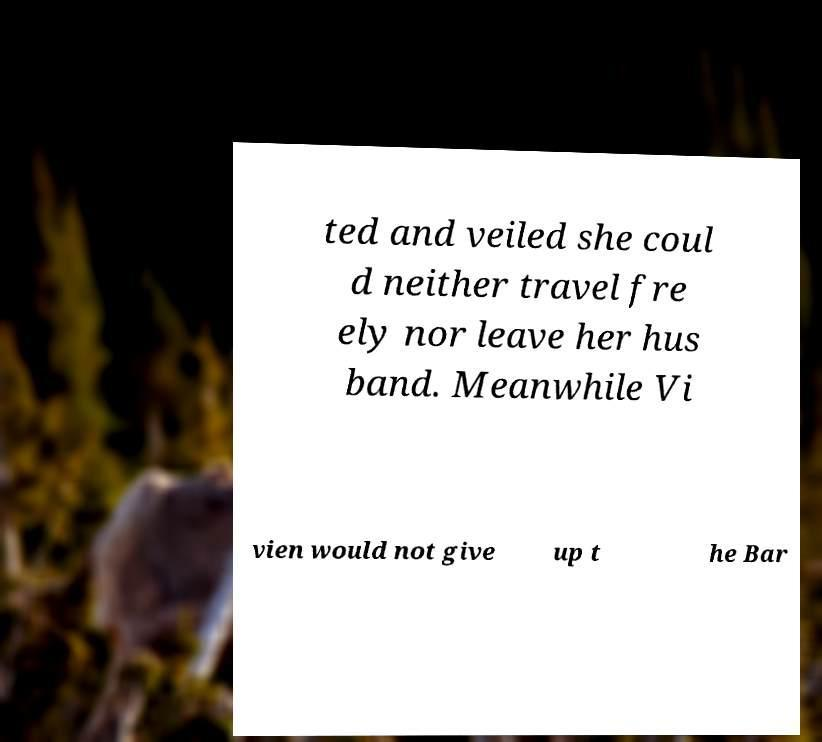Can you accurately transcribe the text from the provided image for me? ted and veiled she coul d neither travel fre ely nor leave her hus band. Meanwhile Vi vien would not give up t he Bar 